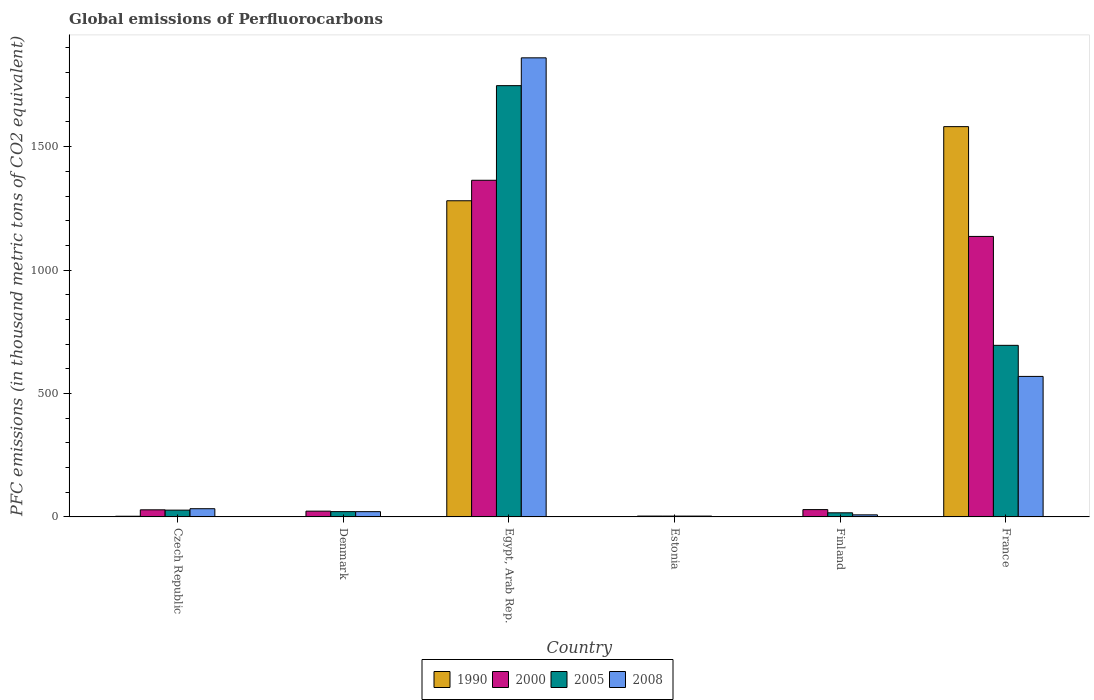How many different coloured bars are there?
Offer a very short reply. 4. How many bars are there on the 6th tick from the left?
Your answer should be very brief. 4. What is the label of the 2nd group of bars from the left?
Your answer should be very brief. Denmark. What is the global emissions of Perfluorocarbons in 1990 in Finland?
Your answer should be very brief. 1.7. Across all countries, what is the maximum global emissions of Perfluorocarbons in 2005?
Give a very brief answer. 1747.1. Across all countries, what is the minimum global emissions of Perfluorocarbons in 1990?
Offer a terse response. 0.5. In which country was the global emissions of Perfluorocarbons in 2008 maximum?
Your answer should be compact. Egypt, Arab Rep. In which country was the global emissions of Perfluorocarbons in 2005 minimum?
Give a very brief answer. Estonia. What is the total global emissions of Perfluorocarbons in 1990 in the graph?
Offer a very short reply. 2868.3. What is the difference between the global emissions of Perfluorocarbons in 1990 in Finland and that in France?
Offer a terse response. -1579.4. What is the difference between the global emissions of Perfluorocarbons in 2005 in Denmark and the global emissions of Perfluorocarbons in 2008 in Czech Republic?
Make the answer very short. -11.8. What is the average global emissions of Perfluorocarbons in 1990 per country?
Your answer should be compact. 478.05. What is the difference between the global emissions of Perfluorocarbons of/in 2005 and global emissions of Perfluorocarbons of/in 2000 in Finland?
Ensure brevity in your answer.  -13. In how many countries, is the global emissions of Perfluorocarbons in 2008 greater than 700 thousand metric tons?
Provide a short and direct response. 1. What is the ratio of the global emissions of Perfluorocarbons in 2005 in Egypt, Arab Rep. to that in France?
Your answer should be compact. 2.51. Is the global emissions of Perfluorocarbons in 1990 in Egypt, Arab Rep. less than that in Finland?
Your answer should be compact. No. Is the difference between the global emissions of Perfluorocarbons in 2005 in Czech Republic and Denmark greater than the difference between the global emissions of Perfluorocarbons in 2000 in Czech Republic and Denmark?
Ensure brevity in your answer.  Yes. What is the difference between the highest and the second highest global emissions of Perfluorocarbons in 2005?
Offer a very short reply. -1719.6. What is the difference between the highest and the lowest global emissions of Perfluorocarbons in 2005?
Provide a short and direct response. 1743.7. Is it the case that in every country, the sum of the global emissions of Perfluorocarbons in 2000 and global emissions of Perfluorocarbons in 2005 is greater than the sum of global emissions of Perfluorocarbons in 1990 and global emissions of Perfluorocarbons in 2008?
Your answer should be compact. No. What does the 4th bar from the left in Finland represents?
Offer a terse response. 2008. What does the 2nd bar from the right in Finland represents?
Give a very brief answer. 2005. Are the values on the major ticks of Y-axis written in scientific E-notation?
Your response must be concise. No. Does the graph contain grids?
Your answer should be very brief. No. How many legend labels are there?
Offer a very short reply. 4. How are the legend labels stacked?
Offer a very short reply. Horizontal. What is the title of the graph?
Ensure brevity in your answer.  Global emissions of Perfluorocarbons. What is the label or title of the X-axis?
Your answer should be compact. Country. What is the label or title of the Y-axis?
Your answer should be compact. PFC emissions (in thousand metric tons of CO2 equivalent). What is the PFC emissions (in thousand metric tons of CO2 equivalent) of 1990 in Czech Republic?
Offer a terse response. 2.8. What is the PFC emissions (in thousand metric tons of CO2 equivalent) of 2000 in Czech Republic?
Provide a short and direct response. 28.8. What is the PFC emissions (in thousand metric tons of CO2 equivalent) of 2008 in Czech Republic?
Give a very brief answer. 33.3. What is the PFC emissions (in thousand metric tons of CO2 equivalent) of 1990 in Denmark?
Keep it short and to the point. 1.4. What is the PFC emissions (in thousand metric tons of CO2 equivalent) in 2000 in Denmark?
Keep it short and to the point. 23.4. What is the PFC emissions (in thousand metric tons of CO2 equivalent) of 2005 in Denmark?
Provide a succinct answer. 21.5. What is the PFC emissions (in thousand metric tons of CO2 equivalent) of 2008 in Denmark?
Your response must be concise. 21.4. What is the PFC emissions (in thousand metric tons of CO2 equivalent) in 1990 in Egypt, Arab Rep.?
Provide a short and direct response. 1280.8. What is the PFC emissions (in thousand metric tons of CO2 equivalent) of 2000 in Egypt, Arab Rep.?
Keep it short and to the point. 1363.8. What is the PFC emissions (in thousand metric tons of CO2 equivalent) in 2005 in Egypt, Arab Rep.?
Make the answer very short. 1747.1. What is the PFC emissions (in thousand metric tons of CO2 equivalent) in 2008 in Egypt, Arab Rep.?
Your answer should be compact. 1859.8. What is the PFC emissions (in thousand metric tons of CO2 equivalent) of 1990 in Estonia?
Ensure brevity in your answer.  0.5. What is the PFC emissions (in thousand metric tons of CO2 equivalent) of 2005 in Estonia?
Provide a succinct answer. 3.4. What is the PFC emissions (in thousand metric tons of CO2 equivalent) of 2008 in Estonia?
Your answer should be compact. 3.4. What is the PFC emissions (in thousand metric tons of CO2 equivalent) in 1990 in Finland?
Ensure brevity in your answer.  1.7. What is the PFC emissions (in thousand metric tons of CO2 equivalent) of 2000 in Finland?
Your response must be concise. 29.7. What is the PFC emissions (in thousand metric tons of CO2 equivalent) in 2005 in Finland?
Give a very brief answer. 16.7. What is the PFC emissions (in thousand metric tons of CO2 equivalent) of 2008 in Finland?
Make the answer very short. 8.4. What is the PFC emissions (in thousand metric tons of CO2 equivalent) in 1990 in France?
Keep it short and to the point. 1581.1. What is the PFC emissions (in thousand metric tons of CO2 equivalent) in 2000 in France?
Your response must be concise. 1136.3. What is the PFC emissions (in thousand metric tons of CO2 equivalent) of 2005 in France?
Provide a succinct answer. 695.1. What is the PFC emissions (in thousand metric tons of CO2 equivalent) in 2008 in France?
Your response must be concise. 569.2. Across all countries, what is the maximum PFC emissions (in thousand metric tons of CO2 equivalent) in 1990?
Provide a short and direct response. 1581.1. Across all countries, what is the maximum PFC emissions (in thousand metric tons of CO2 equivalent) in 2000?
Offer a very short reply. 1363.8. Across all countries, what is the maximum PFC emissions (in thousand metric tons of CO2 equivalent) in 2005?
Keep it short and to the point. 1747.1. Across all countries, what is the maximum PFC emissions (in thousand metric tons of CO2 equivalent) in 2008?
Give a very brief answer. 1859.8. Across all countries, what is the minimum PFC emissions (in thousand metric tons of CO2 equivalent) in 2000?
Ensure brevity in your answer.  3.5. What is the total PFC emissions (in thousand metric tons of CO2 equivalent) in 1990 in the graph?
Your answer should be very brief. 2868.3. What is the total PFC emissions (in thousand metric tons of CO2 equivalent) in 2000 in the graph?
Ensure brevity in your answer.  2585.5. What is the total PFC emissions (in thousand metric tons of CO2 equivalent) in 2005 in the graph?
Your answer should be compact. 2511.3. What is the total PFC emissions (in thousand metric tons of CO2 equivalent) of 2008 in the graph?
Make the answer very short. 2495.5. What is the difference between the PFC emissions (in thousand metric tons of CO2 equivalent) of 2000 in Czech Republic and that in Denmark?
Give a very brief answer. 5.4. What is the difference between the PFC emissions (in thousand metric tons of CO2 equivalent) in 2008 in Czech Republic and that in Denmark?
Ensure brevity in your answer.  11.9. What is the difference between the PFC emissions (in thousand metric tons of CO2 equivalent) in 1990 in Czech Republic and that in Egypt, Arab Rep.?
Your response must be concise. -1278. What is the difference between the PFC emissions (in thousand metric tons of CO2 equivalent) in 2000 in Czech Republic and that in Egypt, Arab Rep.?
Provide a short and direct response. -1335. What is the difference between the PFC emissions (in thousand metric tons of CO2 equivalent) in 2005 in Czech Republic and that in Egypt, Arab Rep.?
Keep it short and to the point. -1719.6. What is the difference between the PFC emissions (in thousand metric tons of CO2 equivalent) in 2008 in Czech Republic and that in Egypt, Arab Rep.?
Your answer should be very brief. -1826.5. What is the difference between the PFC emissions (in thousand metric tons of CO2 equivalent) in 2000 in Czech Republic and that in Estonia?
Offer a very short reply. 25.3. What is the difference between the PFC emissions (in thousand metric tons of CO2 equivalent) in 2005 in Czech Republic and that in Estonia?
Your answer should be compact. 24.1. What is the difference between the PFC emissions (in thousand metric tons of CO2 equivalent) in 2008 in Czech Republic and that in Estonia?
Make the answer very short. 29.9. What is the difference between the PFC emissions (in thousand metric tons of CO2 equivalent) in 1990 in Czech Republic and that in Finland?
Give a very brief answer. 1.1. What is the difference between the PFC emissions (in thousand metric tons of CO2 equivalent) of 2008 in Czech Republic and that in Finland?
Offer a very short reply. 24.9. What is the difference between the PFC emissions (in thousand metric tons of CO2 equivalent) of 1990 in Czech Republic and that in France?
Your answer should be compact. -1578.3. What is the difference between the PFC emissions (in thousand metric tons of CO2 equivalent) of 2000 in Czech Republic and that in France?
Ensure brevity in your answer.  -1107.5. What is the difference between the PFC emissions (in thousand metric tons of CO2 equivalent) in 2005 in Czech Republic and that in France?
Your answer should be very brief. -667.6. What is the difference between the PFC emissions (in thousand metric tons of CO2 equivalent) of 2008 in Czech Republic and that in France?
Provide a succinct answer. -535.9. What is the difference between the PFC emissions (in thousand metric tons of CO2 equivalent) of 1990 in Denmark and that in Egypt, Arab Rep.?
Your answer should be compact. -1279.4. What is the difference between the PFC emissions (in thousand metric tons of CO2 equivalent) of 2000 in Denmark and that in Egypt, Arab Rep.?
Your answer should be compact. -1340.4. What is the difference between the PFC emissions (in thousand metric tons of CO2 equivalent) of 2005 in Denmark and that in Egypt, Arab Rep.?
Make the answer very short. -1725.6. What is the difference between the PFC emissions (in thousand metric tons of CO2 equivalent) in 2008 in Denmark and that in Egypt, Arab Rep.?
Ensure brevity in your answer.  -1838.4. What is the difference between the PFC emissions (in thousand metric tons of CO2 equivalent) of 1990 in Denmark and that in Estonia?
Give a very brief answer. 0.9. What is the difference between the PFC emissions (in thousand metric tons of CO2 equivalent) of 2000 in Denmark and that in Estonia?
Offer a terse response. 19.9. What is the difference between the PFC emissions (in thousand metric tons of CO2 equivalent) in 2005 in Denmark and that in Estonia?
Keep it short and to the point. 18.1. What is the difference between the PFC emissions (in thousand metric tons of CO2 equivalent) in 1990 in Denmark and that in Finland?
Offer a terse response. -0.3. What is the difference between the PFC emissions (in thousand metric tons of CO2 equivalent) in 2000 in Denmark and that in Finland?
Give a very brief answer. -6.3. What is the difference between the PFC emissions (in thousand metric tons of CO2 equivalent) in 2008 in Denmark and that in Finland?
Ensure brevity in your answer.  13. What is the difference between the PFC emissions (in thousand metric tons of CO2 equivalent) of 1990 in Denmark and that in France?
Offer a terse response. -1579.7. What is the difference between the PFC emissions (in thousand metric tons of CO2 equivalent) in 2000 in Denmark and that in France?
Offer a very short reply. -1112.9. What is the difference between the PFC emissions (in thousand metric tons of CO2 equivalent) in 2005 in Denmark and that in France?
Give a very brief answer. -673.6. What is the difference between the PFC emissions (in thousand metric tons of CO2 equivalent) of 2008 in Denmark and that in France?
Your answer should be compact. -547.8. What is the difference between the PFC emissions (in thousand metric tons of CO2 equivalent) in 1990 in Egypt, Arab Rep. and that in Estonia?
Your response must be concise. 1280.3. What is the difference between the PFC emissions (in thousand metric tons of CO2 equivalent) in 2000 in Egypt, Arab Rep. and that in Estonia?
Your response must be concise. 1360.3. What is the difference between the PFC emissions (in thousand metric tons of CO2 equivalent) in 2005 in Egypt, Arab Rep. and that in Estonia?
Your answer should be compact. 1743.7. What is the difference between the PFC emissions (in thousand metric tons of CO2 equivalent) in 2008 in Egypt, Arab Rep. and that in Estonia?
Your response must be concise. 1856.4. What is the difference between the PFC emissions (in thousand metric tons of CO2 equivalent) in 1990 in Egypt, Arab Rep. and that in Finland?
Make the answer very short. 1279.1. What is the difference between the PFC emissions (in thousand metric tons of CO2 equivalent) of 2000 in Egypt, Arab Rep. and that in Finland?
Ensure brevity in your answer.  1334.1. What is the difference between the PFC emissions (in thousand metric tons of CO2 equivalent) in 2005 in Egypt, Arab Rep. and that in Finland?
Make the answer very short. 1730.4. What is the difference between the PFC emissions (in thousand metric tons of CO2 equivalent) of 2008 in Egypt, Arab Rep. and that in Finland?
Provide a short and direct response. 1851.4. What is the difference between the PFC emissions (in thousand metric tons of CO2 equivalent) of 1990 in Egypt, Arab Rep. and that in France?
Provide a succinct answer. -300.3. What is the difference between the PFC emissions (in thousand metric tons of CO2 equivalent) of 2000 in Egypt, Arab Rep. and that in France?
Your response must be concise. 227.5. What is the difference between the PFC emissions (in thousand metric tons of CO2 equivalent) of 2005 in Egypt, Arab Rep. and that in France?
Provide a short and direct response. 1052. What is the difference between the PFC emissions (in thousand metric tons of CO2 equivalent) of 2008 in Egypt, Arab Rep. and that in France?
Your response must be concise. 1290.6. What is the difference between the PFC emissions (in thousand metric tons of CO2 equivalent) of 1990 in Estonia and that in Finland?
Provide a succinct answer. -1.2. What is the difference between the PFC emissions (in thousand metric tons of CO2 equivalent) of 2000 in Estonia and that in Finland?
Your answer should be very brief. -26.2. What is the difference between the PFC emissions (in thousand metric tons of CO2 equivalent) in 2005 in Estonia and that in Finland?
Give a very brief answer. -13.3. What is the difference between the PFC emissions (in thousand metric tons of CO2 equivalent) in 2008 in Estonia and that in Finland?
Give a very brief answer. -5. What is the difference between the PFC emissions (in thousand metric tons of CO2 equivalent) in 1990 in Estonia and that in France?
Your answer should be compact. -1580.6. What is the difference between the PFC emissions (in thousand metric tons of CO2 equivalent) in 2000 in Estonia and that in France?
Offer a terse response. -1132.8. What is the difference between the PFC emissions (in thousand metric tons of CO2 equivalent) in 2005 in Estonia and that in France?
Offer a terse response. -691.7. What is the difference between the PFC emissions (in thousand metric tons of CO2 equivalent) in 2008 in Estonia and that in France?
Offer a terse response. -565.8. What is the difference between the PFC emissions (in thousand metric tons of CO2 equivalent) of 1990 in Finland and that in France?
Ensure brevity in your answer.  -1579.4. What is the difference between the PFC emissions (in thousand metric tons of CO2 equivalent) in 2000 in Finland and that in France?
Your answer should be very brief. -1106.6. What is the difference between the PFC emissions (in thousand metric tons of CO2 equivalent) in 2005 in Finland and that in France?
Give a very brief answer. -678.4. What is the difference between the PFC emissions (in thousand metric tons of CO2 equivalent) in 2008 in Finland and that in France?
Offer a terse response. -560.8. What is the difference between the PFC emissions (in thousand metric tons of CO2 equivalent) of 1990 in Czech Republic and the PFC emissions (in thousand metric tons of CO2 equivalent) of 2000 in Denmark?
Keep it short and to the point. -20.6. What is the difference between the PFC emissions (in thousand metric tons of CO2 equivalent) of 1990 in Czech Republic and the PFC emissions (in thousand metric tons of CO2 equivalent) of 2005 in Denmark?
Your answer should be very brief. -18.7. What is the difference between the PFC emissions (in thousand metric tons of CO2 equivalent) of 1990 in Czech Republic and the PFC emissions (in thousand metric tons of CO2 equivalent) of 2008 in Denmark?
Your answer should be very brief. -18.6. What is the difference between the PFC emissions (in thousand metric tons of CO2 equivalent) of 1990 in Czech Republic and the PFC emissions (in thousand metric tons of CO2 equivalent) of 2000 in Egypt, Arab Rep.?
Your answer should be very brief. -1361. What is the difference between the PFC emissions (in thousand metric tons of CO2 equivalent) in 1990 in Czech Republic and the PFC emissions (in thousand metric tons of CO2 equivalent) in 2005 in Egypt, Arab Rep.?
Give a very brief answer. -1744.3. What is the difference between the PFC emissions (in thousand metric tons of CO2 equivalent) of 1990 in Czech Republic and the PFC emissions (in thousand metric tons of CO2 equivalent) of 2008 in Egypt, Arab Rep.?
Ensure brevity in your answer.  -1857. What is the difference between the PFC emissions (in thousand metric tons of CO2 equivalent) in 2000 in Czech Republic and the PFC emissions (in thousand metric tons of CO2 equivalent) in 2005 in Egypt, Arab Rep.?
Offer a very short reply. -1718.3. What is the difference between the PFC emissions (in thousand metric tons of CO2 equivalent) in 2000 in Czech Republic and the PFC emissions (in thousand metric tons of CO2 equivalent) in 2008 in Egypt, Arab Rep.?
Your answer should be compact. -1831. What is the difference between the PFC emissions (in thousand metric tons of CO2 equivalent) in 2005 in Czech Republic and the PFC emissions (in thousand metric tons of CO2 equivalent) in 2008 in Egypt, Arab Rep.?
Provide a succinct answer. -1832.3. What is the difference between the PFC emissions (in thousand metric tons of CO2 equivalent) in 1990 in Czech Republic and the PFC emissions (in thousand metric tons of CO2 equivalent) in 2000 in Estonia?
Offer a terse response. -0.7. What is the difference between the PFC emissions (in thousand metric tons of CO2 equivalent) of 1990 in Czech Republic and the PFC emissions (in thousand metric tons of CO2 equivalent) of 2008 in Estonia?
Make the answer very short. -0.6. What is the difference between the PFC emissions (in thousand metric tons of CO2 equivalent) in 2000 in Czech Republic and the PFC emissions (in thousand metric tons of CO2 equivalent) in 2005 in Estonia?
Your answer should be compact. 25.4. What is the difference between the PFC emissions (in thousand metric tons of CO2 equivalent) in 2000 in Czech Republic and the PFC emissions (in thousand metric tons of CO2 equivalent) in 2008 in Estonia?
Keep it short and to the point. 25.4. What is the difference between the PFC emissions (in thousand metric tons of CO2 equivalent) of 2005 in Czech Republic and the PFC emissions (in thousand metric tons of CO2 equivalent) of 2008 in Estonia?
Keep it short and to the point. 24.1. What is the difference between the PFC emissions (in thousand metric tons of CO2 equivalent) of 1990 in Czech Republic and the PFC emissions (in thousand metric tons of CO2 equivalent) of 2000 in Finland?
Ensure brevity in your answer.  -26.9. What is the difference between the PFC emissions (in thousand metric tons of CO2 equivalent) in 1990 in Czech Republic and the PFC emissions (in thousand metric tons of CO2 equivalent) in 2008 in Finland?
Make the answer very short. -5.6. What is the difference between the PFC emissions (in thousand metric tons of CO2 equivalent) of 2000 in Czech Republic and the PFC emissions (in thousand metric tons of CO2 equivalent) of 2008 in Finland?
Ensure brevity in your answer.  20.4. What is the difference between the PFC emissions (in thousand metric tons of CO2 equivalent) in 1990 in Czech Republic and the PFC emissions (in thousand metric tons of CO2 equivalent) in 2000 in France?
Your answer should be very brief. -1133.5. What is the difference between the PFC emissions (in thousand metric tons of CO2 equivalent) in 1990 in Czech Republic and the PFC emissions (in thousand metric tons of CO2 equivalent) in 2005 in France?
Provide a succinct answer. -692.3. What is the difference between the PFC emissions (in thousand metric tons of CO2 equivalent) in 1990 in Czech Republic and the PFC emissions (in thousand metric tons of CO2 equivalent) in 2008 in France?
Provide a succinct answer. -566.4. What is the difference between the PFC emissions (in thousand metric tons of CO2 equivalent) of 2000 in Czech Republic and the PFC emissions (in thousand metric tons of CO2 equivalent) of 2005 in France?
Make the answer very short. -666.3. What is the difference between the PFC emissions (in thousand metric tons of CO2 equivalent) of 2000 in Czech Republic and the PFC emissions (in thousand metric tons of CO2 equivalent) of 2008 in France?
Your answer should be compact. -540.4. What is the difference between the PFC emissions (in thousand metric tons of CO2 equivalent) of 2005 in Czech Republic and the PFC emissions (in thousand metric tons of CO2 equivalent) of 2008 in France?
Your answer should be compact. -541.7. What is the difference between the PFC emissions (in thousand metric tons of CO2 equivalent) in 1990 in Denmark and the PFC emissions (in thousand metric tons of CO2 equivalent) in 2000 in Egypt, Arab Rep.?
Your answer should be very brief. -1362.4. What is the difference between the PFC emissions (in thousand metric tons of CO2 equivalent) in 1990 in Denmark and the PFC emissions (in thousand metric tons of CO2 equivalent) in 2005 in Egypt, Arab Rep.?
Provide a short and direct response. -1745.7. What is the difference between the PFC emissions (in thousand metric tons of CO2 equivalent) of 1990 in Denmark and the PFC emissions (in thousand metric tons of CO2 equivalent) of 2008 in Egypt, Arab Rep.?
Provide a succinct answer. -1858.4. What is the difference between the PFC emissions (in thousand metric tons of CO2 equivalent) of 2000 in Denmark and the PFC emissions (in thousand metric tons of CO2 equivalent) of 2005 in Egypt, Arab Rep.?
Offer a terse response. -1723.7. What is the difference between the PFC emissions (in thousand metric tons of CO2 equivalent) in 2000 in Denmark and the PFC emissions (in thousand metric tons of CO2 equivalent) in 2008 in Egypt, Arab Rep.?
Offer a very short reply. -1836.4. What is the difference between the PFC emissions (in thousand metric tons of CO2 equivalent) of 2005 in Denmark and the PFC emissions (in thousand metric tons of CO2 equivalent) of 2008 in Egypt, Arab Rep.?
Give a very brief answer. -1838.3. What is the difference between the PFC emissions (in thousand metric tons of CO2 equivalent) of 1990 in Denmark and the PFC emissions (in thousand metric tons of CO2 equivalent) of 2008 in Estonia?
Offer a terse response. -2. What is the difference between the PFC emissions (in thousand metric tons of CO2 equivalent) in 2000 in Denmark and the PFC emissions (in thousand metric tons of CO2 equivalent) in 2008 in Estonia?
Provide a short and direct response. 20. What is the difference between the PFC emissions (in thousand metric tons of CO2 equivalent) of 1990 in Denmark and the PFC emissions (in thousand metric tons of CO2 equivalent) of 2000 in Finland?
Provide a succinct answer. -28.3. What is the difference between the PFC emissions (in thousand metric tons of CO2 equivalent) of 1990 in Denmark and the PFC emissions (in thousand metric tons of CO2 equivalent) of 2005 in Finland?
Your answer should be very brief. -15.3. What is the difference between the PFC emissions (in thousand metric tons of CO2 equivalent) in 2000 in Denmark and the PFC emissions (in thousand metric tons of CO2 equivalent) in 2005 in Finland?
Your response must be concise. 6.7. What is the difference between the PFC emissions (in thousand metric tons of CO2 equivalent) in 2005 in Denmark and the PFC emissions (in thousand metric tons of CO2 equivalent) in 2008 in Finland?
Ensure brevity in your answer.  13.1. What is the difference between the PFC emissions (in thousand metric tons of CO2 equivalent) of 1990 in Denmark and the PFC emissions (in thousand metric tons of CO2 equivalent) of 2000 in France?
Give a very brief answer. -1134.9. What is the difference between the PFC emissions (in thousand metric tons of CO2 equivalent) of 1990 in Denmark and the PFC emissions (in thousand metric tons of CO2 equivalent) of 2005 in France?
Provide a succinct answer. -693.7. What is the difference between the PFC emissions (in thousand metric tons of CO2 equivalent) in 1990 in Denmark and the PFC emissions (in thousand metric tons of CO2 equivalent) in 2008 in France?
Provide a succinct answer. -567.8. What is the difference between the PFC emissions (in thousand metric tons of CO2 equivalent) in 2000 in Denmark and the PFC emissions (in thousand metric tons of CO2 equivalent) in 2005 in France?
Your answer should be compact. -671.7. What is the difference between the PFC emissions (in thousand metric tons of CO2 equivalent) of 2000 in Denmark and the PFC emissions (in thousand metric tons of CO2 equivalent) of 2008 in France?
Provide a succinct answer. -545.8. What is the difference between the PFC emissions (in thousand metric tons of CO2 equivalent) of 2005 in Denmark and the PFC emissions (in thousand metric tons of CO2 equivalent) of 2008 in France?
Make the answer very short. -547.7. What is the difference between the PFC emissions (in thousand metric tons of CO2 equivalent) in 1990 in Egypt, Arab Rep. and the PFC emissions (in thousand metric tons of CO2 equivalent) in 2000 in Estonia?
Make the answer very short. 1277.3. What is the difference between the PFC emissions (in thousand metric tons of CO2 equivalent) of 1990 in Egypt, Arab Rep. and the PFC emissions (in thousand metric tons of CO2 equivalent) of 2005 in Estonia?
Ensure brevity in your answer.  1277.4. What is the difference between the PFC emissions (in thousand metric tons of CO2 equivalent) in 1990 in Egypt, Arab Rep. and the PFC emissions (in thousand metric tons of CO2 equivalent) in 2008 in Estonia?
Make the answer very short. 1277.4. What is the difference between the PFC emissions (in thousand metric tons of CO2 equivalent) of 2000 in Egypt, Arab Rep. and the PFC emissions (in thousand metric tons of CO2 equivalent) of 2005 in Estonia?
Your answer should be compact. 1360.4. What is the difference between the PFC emissions (in thousand metric tons of CO2 equivalent) of 2000 in Egypt, Arab Rep. and the PFC emissions (in thousand metric tons of CO2 equivalent) of 2008 in Estonia?
Offer a very short reply. 1360.4. What is the difference between the PFC emissions (in thousand metric tons of CO2 equivalent) of 2005 in Egypt, Arab Rep. and the PFC emissions (in thousand metric tons of CO2 equivalent) of 2008 in Estonia?
Your answer should be compact. 1743.7. What is the difference between the PFC emissions (in thousand metric tons of CO2 equivalent) in 1990 in Egypt, Arab Rep. and the PFC emissions (in thousand metric tons of CO2 equivalent) in 2000 in Finland?
Ensure brevity in your answer.  1251.1. What is the difference between the PFC emissions (in thousand metric tons of CO2 equivalent) of 1990 in Egypt, Arab Rep. and the PFC emissions (in thousand metric tons of CO2 equivalent) of 2005 in Finland?
Provide a short and direct response. 1264.1. What is the difference between the PFC emissions (in thousand metric tons of CO2 equivalent) in 1990 in Egypt, Arab Rep. and the PFC emissions (in thousand metric tons of CO2 equivalent) in 2008 in Finland?
Your response must be concise. 1272.4. What is the difference between the PFC emissions (in thousand metric tons of CO2 equivalent) in 2000 in Egypt, Arab Rep. and the PFC emissions (in thousand metric tons of CO2 equivalent) in 2005 in Finland?
Make the answer very short. 1347.1. What is the difference between the PFC emissions (in thousand metric tons of CO2 equivalent) of 2000 in Egypt, Arab Rep. and the PFC emissions (in thousand metric tons of CO2 equivalent) of 2008 in Finland?
Give a very brief answer. 1355.4. What is the difference between the PFC emissions (in thousand metric tons of CO2 equivalent) in 2005 in Egypt, Arab Rep. and the PFC emissions (in thousand metric tons of CO2 equivalent) in 2008 in Finland?
Provide a succinct answer. 1738.7. What is the difference between the PFC emissions (in thousand metric tons of CO2 equivalent) in 1990 in Egypt, Arab Rep. and the PFC emissions (in thousand metric tons of CO2 equivalent) in 2000 in France?
Offer a very short reply. 144.5. What is the difference between the PFC emissions (in thousand metric tons of CO2 equivalent) of 1990 in Egypt, Arab Rep. and the PFC emissions (in thousand metric tons of CO2 equivalent) of 2005 in France?
Make the answer very short. 585.7. What is the difference between the PFC emissions (in thousand metric tons of CO2 equivalent) in 1990 in Egypt, Arab Rep. and the PFC emissions (in thousand metric tons of CO2 equivalent) in 2008 in France?
Provide a succinct answer. 711.6. What is the difference between the PFC emissions (in thousand metric tons of CO2 equivalent) in 2000 in Egypt, Arab Rep. and the PFC emissions (in thousand metric tons of CO2 equivalent) in 2005 in France?
Provide a succinct answer. 668.7. What is the difference between the PFC emissions (in thousand metric tons of CO2 equivalent) in 2000 in Egypt, Arab Rep. and the PFC emissions (in thousand metric tons of CO2 equivalent) in 2008 in France?
Make the answer very short. 794.6. What is the difference between the PFC emissions (in thousand metric tons of CO2 equivalent) in 2005 in Egypt, Arab Rep. and the PFC emissions (in thousand metric tons of CO2 equivalent) in 2008 in France?
Offer a very short reply. 1177.9. What is the difference between the PFC emissions (in thousand metric tons of CO2 equivalent) of 1990 in Estonia and the PFC emissions (in thousand metric tons of CO2 equivalent) of 2000 in Finland?
Make the answer very short. -29.2. What is the difference between the PFC emissions (in thousand metric tons of CO2 equivalent) in 1990 in Estonia and the PFC emissions (in thousand metric tons of CO2 equivalent) in 2005 in Finland?
Provide a short and direct response. -16.2. What is the difference between the PFC emissions (in thousand metric tons of CO2 equivalent) of 1990 in Estonia and the PFC emissions (in thousand metric tons of CO2 equivalent) of 2008 in Finland?
Keep it short and to the point. -7.9. What is the difference between the PFC emissions (in thousand metric tons of CO2 equivalent) in 2000 in Estonia and the PFC emissions (in thousand metric tons of CO2 equivalent) in 2008 in Finland?
Give a very brief answer. -4.9. What is the difference between the PFC emissions (in thousand metric tons of CO2 equivalent) of 2005 in Estonia and the PFC emissions (in thousand metric tons of CO2 equivalent) of 2008 in Finland?
Provide a short and direct response. -5. What is the difference between the PFC emissions (in thousand metric tons of CO2 equivalent) of 1990 in Estonia and the PFC emissions (in thousand metric tons of CO2 equivalent) of 2000 in France?
Your response must be concise. -1135.8. What is the difference between the PFC emissions (in thousand metric tons of CO2 equivalent) of 1990 in Estonia and the PFC emissions (in thousand metric tons of CO2 equivalent) of 2005 in France?
Your answer should be very brief. -694.6. What is the difference between the PFC emissions (in thousand metric tons of CO2 equivalent) in 1990 in Estonia and the PFC emissions (in thousand metric tons of CO2 equivalent) in 2008 in France?
Ensure brevity in your answer.  -568.7. What is the difference between the PFC emissions (in thousand metric tons of CO2 equivalent) in 2000 in Estonia and the PFC emissions (in thousand metric tons of CO2 equivalent) in 2005 in France?
Keep it short and to the point. -691.6. What is the difference between the PFC emissions (in thousand metric tons of CO2 equivalent) of 2000 in Estonia and the PFC emissions (in thousand metric tons of CO2 equivalent) of 2008 in France?
Give a very brief answer. -565.7. What is the difference between the PFC emissions (in thousand metric tons of CO2 equivalent) in 2005 in Estonia and the PFC emissions (in thousand metric tons of CO2 equivalent) in 2008 in France?
Make the answer very short. -565.8. What is the difference between the PFC emissions (in thousand metric tons of CO2 equivalent) of 1990 in Finland and the PFC emissions (in thousand metric tons of CO2 equivalent) of 2000 in France?
Your answer should be compact. -1134.6. What is the difference between the PFC emissions (in thousand metric tons of CO2 equivalent) in 1990 in Finland and the PFC emissions (in thousand metric tons of CO2 equivalent) in 2005 in France?
Your answer should be compact. -693.4. What is the difference between the PFC emissions (in thousand metric tons of CO2 equivalent) of 1990 in Finland and the PFC emissions (in thousand metric tons of CO2 equivalent) of 2008 in France?
Your answer should be very brief. -567.5. What is the difference between the PFC emissions (in thousand metric tons of CO2 equivalent) of 2000 in Finland and the PFC emissions (in thousand metric tons of CO2 equivalent) of 2005 in France?
Offer a very short reply. -665.4. What is the difference between the PFC emissions (in thousand metric tons of CO2 equivalent) of 2000 in Finland and the PFC emissions (in thousand metric tons of CO2 equivalent) of 2008 in France?
Make the answer very short. -539.5. What is the difference between the PFC emissions (in thousand metric tons of CO2 equivalent) of 2005 in Finland and the PFC emissions (in thousand metric tons of CO2 equivalent) of 2008 in France?
Ensure brevity in your answer.  -552.5. What is the average PFC emissions (in thousand metric tons of CO2 equivalent) of 1990 per country?
Keep it short and to the point. 478.05. What is the average PFC emissions (in thousand metric tons of CO2 equivalent) of 2000 per country?
Ensure brevity in your answer.  430.92. What is the average PFC emissions (in thousand metric tons of CO2 equivalent) in 2005 per country?
Offer a very short reply. 418.55. What is the average PFC emissions (in thousand metric tons of CO2 equivalent) of 2008 per country?
Offer a very short reply. 415.92. What is the difference between the PFC emissions (in thousand metric tons of CO2 equivalent) in 1990 and PFC emissions (in thousand metric tons of CO2 equivalent) in 2000 in Czech Republic?
Your answer should be compact. -26. What is the difference between the PFC emissions (in thousand metric tons of CO2 equivalent) in 1990 and PFC emissions (in thousand metric tons of CO2 equivalent) in 2005 in Czech Republic?
Provide a succinct answer. -24.7. What is the difference between the PFC emissions (in thousand metric tons of CO2 equivalent) of 1990 and PFC emissions (in thousand metric tons of CO2 equivalent) of 2008 in Czech Republic?
Provide a succinct answer. -30.5. What is the difference between the PFC emissions (in thousand metric tons of CO2 equivalent) in 1990 and PFC emissions (in thousand metric tons of CO2 equivalent) in 2005 in Denmark?
Your answer should be very brief. -20.1. What is the difference between the PFC emissions (in thousand metric tons of CO2 equivalent) in 2000 and PFC emissions (in thousand metric tons of CO2 equivalent) in 2005 in Denmark?
Your answer should be compact. 1.9. What is the difference between the PFC emissions (in thousand metric tons of CO2 equivalent) in 2005 and PFC emissions (in thousand metric tons of CO2 equivalent) in 2008 in Denmark?
Give a very brief answer. 0.1. What is the difference between the PFC emissions (in thousand metric tons of CO2 equivalent) of 1990 and PFC emissions (in thousand metric tons of CO2 equivalent) of 2000 in Egypt, Arab Rep.?
Your response must be concise. -83. What is the difference between the PFC emissions (in thousand metric tons of CO2 equivalent) in 1990 and PFC emissions (in thousand metric tons of CO2 equivalent) in 2005 in Egypt, Arab Rep.?
Provide a short and direct response. -466.3. What is the difference between the PFC emissions (in thousand metric tons of CO2 equivalent) of 1990 and PFC emissions (in thousand metric tons of CO2 equivalent) of 2008 in Egypt, Arab Rep.?
Keep it short and to the point. -579. What is the difference between the PFC emissions (in thousand metric tons of CO2 equivalent) in 2000 and PFC emissions (in thousand metric tons of CO2 equivalent) in 2005 in Egypt, Arab Rep.?
Provide a succinct answer. -383.3. What is the difference between the PFC emissions (in thousand metric tons of CO2 equivalent) of 2000 and PFC emissions (in thousand metric tons of CO2 equivalent) of 2008 in Egypt, Arab Rep.?
Offer a terse response. -496. What is the difference between the PFC emissions (in thousand metric tons of CO2 equivalent) in 2005 and PFC emissions (in thousand metric tons of CO2 equivalent) in 2008 in Egypt, Arab Rep.?
Ensure brevity in your answer.  -112.7. What is the difference between the PFC emissions (in thousand metric tons of CO2 equivalent) in 2000 and PFC emissions (in thousand metric tons of CO2 equivalent) in 2005 in Estonia?
Your answer should be compact. 0.1. What is the difference between the PFC emissions (in thousand metric tons of CO2 equivalent) of 1990 and PFC emissions (in thousand metric tons of CO2 equivalent) of 2005 in Finland?
Ensure brevity in your answer.  -15. What is the difference between the PFC emissions (in thousand metric tons of CO2 equivalent) in 1990 and PFC emissions (in thousand metric tons of CO2 equivalent) in 2008 in Finland?
Give a very brief answer. -6.7. What is the difference between the PFC emissions (in thousand metric tons of CO2 equivalent) of 2000 and PFC emissions (in thousand metric tons of CO2 equivalent) of 2008 in Finland?
Provide a short and direct response. 21.3. What is the difference between the PFC emissions (in thousand metric tons of CO2 equivalent) of 1990 and PFC emissions (in thousand metric tons of CO2 equivalent) of 2000 in France?
Offer a very short reply. 444.8. What is the difference between the PFC emissions (in thousand metric tons of CO2 equivalent) in 1990 and PFC emissions (in thousand metric tons of CO2 equivalent) in 2005 in France?
Your answer should be compact. 886. What is the difference between the PFC emissions (in thousand metric tons of CO2 equivalent) in 1990 and PFC emissions (in thousand metric tons of CO2 equivalent) in 2008 in France?
Offer a very short reply. 1011.9. What is the difference between the PFC emissions (in thousand metric tons of CO2 equivalent) in 2000 and PFC emissions (in thousand metric tons of CO2 equivalent) in 2005 in France?
Keep it short and to the point. 441.2. What is the difference between the PFC emissions (in thousand metric tons of CO2 equivalent) in 2000 and PFC emissions (in thousand metric tons of CO2 equivalent) in 2008 in France?
Ensure brevity in your answer.  567.1. What is the difference between the PFC emissions (in thousand metric tons of CO2 equivalent) of 2005 and PFC emissions (in thousand metric tons of CO2 equivalent) of 2008 in France?
Your answer should be compact. 125.9. What is the ratio of the PFC emissions (in thousand metric tons of CO2 equivalent) in 2000 in Czech Republic to that in Denmark?
Your answer should be compact. 1.23. What is the ratio of the PFC emissions (in thousand metric tons of CO2 equivalent) in 2005 in Czech Republic to that in Denmark?
Your response must be concise. 1.28. What is the ratio of the PFC emissions (in thousand metric tons of CO2 equivalent) of 2008 in Czech Republic to that in Denmark?
Your answer should be very brief. 1.56. What is the ratio of the PFC emissions (in thousand metric tons of CO2 equivalent) of 1990 in Czech Republic to that in Egypt, Arab Rep.?
Provide a short and direct response. 0. What is the ratio of the PFC emissions (in thousand metric tons of CO2 equivalent) in 2000 in Czech Republic to that in Egypt, Arab Rep.?
Your answer should be very brief. 0.02. What is the ratio of the PFC emissions (in thousand metric tons of CO2 equivalent) in 2005 in Czech Republic to that in Egypt, Arab Rep.?
Offer a very short reply. 0.02. What is the ratio of the PFC emissions (in thousand metric tons of CO2 equivalent) of 2008 in Czech Republic to that in Egypt, Arab Rep.?
Ensure brevity in your answer.  0.02. What is the ratio of the PFC emissions (in thousand metric tons of CO2 equivalent) of 1990 in Czech Republic to that in Estonia?
Offer a terse response. 5.6. What is the ratio of the PFC emissions (in thousand metric tons of CO2 equivalent) in 2000 in Czech Republic to that in Estonia?
Your answer should be very brief. 8.23. What is the ratio of the PFC emissions (in thousand metric tons of CO2 equivalent) in 2005 in Czech Republic to that in Estonia?
Offer a terse response. 8.09. What is the ratio of the PFC emissions (in thousand metric tons of CO2 equivalent) in 2008 in Czech Republic to that in Estonia?
Your answer should be very brief. 9.79. What is the ratio of the PFC emissions (in thousand metric tons of CO2 equivalent) of 1990 in Czech Republic to that in Finland?
Your answer should be very brief. 1.65. What is the ratio of the PFC emissions (in thousand metric tons of CO2 equivalent) of 2000 in Czech Republic to that in Finland?
Your answer should be compact. 0.97. What is the ratio of the PFC emissions (in thousand metric tons of CO2 equivalent) in 2005 in Czech Republic to that in Finland?
Provide a succinct answer. 1.65. What is the ratio of the PFC emissions (in thousand metric tons of CO2 equivalent) in 2008 in Czech Republic to that in Finland?
Give a very brief answer. 3.96. What is the ratio of the PFC emissions (in thousand metric tons of CO2 equivalent) of 1990 in Czech Republic to that in France?
Offer a terse response. 0. What is the ratio of the PFC emissions (in thousand metric tons of CO2 equivalent) of 2000 in Czech Republic to that in France?
Keep it short and to the point. 0.03. What is the ratio of the PFC emissions (in thousand metric tons of CO2 equivalent) of 2005 in Czech Republic to that in France?
Keep it short and to the point. 0.04. What is the ratio of the PFC emissions (in thousand metric tons of CO2 equivalent) of 2008 in Czech Republic to that in France?
Give a very brief answer. 0.06. What is the ratio of the PFC emissions (in thousand metric tons of CO2 equivalent) of 1990 in Denmark to that in Egypt, Arab Rep.?
Make the answer very short. 0. What is the ratio of the PFC emissions (in thousand metric tons of CO2 equivalent) in 2000 in Denmark to that in Egypt, Arab Rep.?
Ensure brevity in your answer.  0.02. What is the ratio of the PFC emissions (in thousand metric tons of CO2 equivalent) in 2005 in Denmark to that in Egypt, Arab Rep.?
Keep it short and to the point. 0.01. What is the ratio of the PFC emissions (in thousand metric tons of CO2 equivalent) in 2008 in Denmark to that in Egypt, Arab Rep.?
Your answer should be very brief. 0.01. What is the ratio of the PFC emissions (in thousand metric tons of CO2 equivalent) in 2000 in Denmark to that in Estonia?
Your answer should be compact. 6.69. What is the ratio of the PFC emissions (in thousand metric tons of CO2 equivalent) in 2005 in Denmark to that in Estonia?
Provide a short and direct response. 6.32. What is the ratio of the PFC emissions (in thousand metric tons of CO2 equivalent) in 2008 in Denmark to that in Estonia?
Give a very brief answer. 6.29. What is the ratio of the PFC emissions (in thousand metric tons of CO2 equivalent) of 1990 in Denmark to that in Finland?
Your response must be concise. 0.82. What is the ratio of the PFC emissions (in thousand metric tons of CO2 equivalent) of 2000 in Denmark to that in Finland?
Offer a terse response. 0.79. What is the ratio of the PFC emissions (in thousand metric tons of CO2 equivalent) in 2005 in Denmark to that in Finland?
Offer a terse response. 1.29. What is the ratio of the PFC emissions (in thousand metric tons of CO2 equivalent) in 2008 in Denmark to that in Finland?
Provide a short and direct response. 2.55. What is the ratio of the PFC emissions (in thousand metric tons of CO2 equivalent) in 1990 in Denmark to that in France?
Offer a very short reply. 0. What is the ratio of the PFC emissions (in thousand metric tons of CO2 equivalent) in 2000 in Denmark to that in France?
Offer a very short reply. 0.02. What is the ratio of the PFC emissions (in thousand metric tons of CO2 equivalent) in 2005 in Denmark to that in France?
Keep it short and to the point. 0.03. What is the ratio of the PFC emissions (in thousand metric tons of CO2 equivalent) in 2008 in Denmark to that in France?
Give a very brief answer. 0.04. What is the ratio of the PFC emissions (in thousand metric tons of CO2 equivalent) of 1990 in Egypt, Arab Rep. to that in Estonia?
Offer a very short reply. 2561.6. What is the ratio of the PFC emissions (in thousand metric tons of CO2 equivalent) in 2000 in Egypt, Arab Rep. to that in Estonia?
Your answer should be compact. 389.66. What is the ratio of the PFC emissions (in thousand metric tons of CO2 equivalent) of 2005 in Egypt, Arab Rep. to that in Estonia?
Keep it short and to the point. 513.85. What is the ratio of the PFC emissions (in thousand metric tons of CO2 equivalent) of 2008 in Egypt, Arab Rep. to that in Estonia?
Your answer should be compact. 547. What is the ratio of the PFC emissions (in thousand metric tons of CO2 equivalent) of 1990 in Egypt, Arab Rep. to that in Finland?
Keep it short and to the point. 753.41. What is the ratio of the PFC emissions (in thousand metric tons of CO2 equivalent) in 2000 in Egypt, Arab Rep. to that in Finland?
Your response must be concise. 45.92. What is the ratio of the PFC emissions (in thousand metric tons of CO2 equivalent) in 2005 in Egypt, Arab Rep. to that in Finland?
Offer a terse response. 104.62. What is the ratio of the PFC emissions (in thousand metric tons of CO2 equivalent) of 2008 in Egypt, Arab Rep. to that in Finland?
Your response must be concise. 221.4. What is the ratio of the PFC emissions (in thousand metric tons of CO2 equivalent) of 1990 in Egypt, Arab Rep. to that in France?
Your response must be concise. 0.81. What is the ratio of the PFC emissions (in thousand metric tons of CO2 equivalent) in 2000 in Egypt, Arab Rep. to that in France?
Provide a succinct answer. 1.2. What is the ratio of the PFC emissions (in thousand metric tons of CO2 equivalent) in 2005 in Egypt, Arab Rep. to that in France?
Your answer should be very brief. 2.51. What is the ratio of the PFC emissions (in thousand metric tons of CO2 equivalent) of 2008 in Egypt, Arab Rep. to that in France?
Your answer should be compact. 3.27. What is the ratio of the PFC emissions (in thousand metric tons of CO2 equivalent) of 1990 in Estonia to that in Finland?
Make the answer very short. 0.29. What is the ratio of the PFC emissions (in thousand metric tons of CO2 equivalent) in 2000 in Estonia to that in Finland?
Your answer should be very brief. 0.12. What is the ratio of the PFC emissions (in thousand metric tons of CO2 equivalent) in 2005 in Estonia to that in Finland?
Your response must be concise. 0.2. What is the ratio of the PFC emissions (in thousand metric tons of CO2 equivalent) of 2008 in Estonia to that in Finland?
Keep it short and to the point. 0.4. What is the ratio of the PFC emissions (in thousand metric tons of CO2 equivalent) in 1990 in Estonia to that in France?
Offer a very short reply. 0. What is the ratio of the PFC emissions (in thousand metric tons of CO2 equivalent) in 2000 in Estonia to that in France?
Give a very brief answer. 0. What is the ratio of the PFC emissions (in thousand metric tons of CO2 equivalent) in 2005 in Estonia to that in France?
Your answer should be compact. 0. What is the ratio of the PFC emissions (in thousand metric tons of CO2 equivalent) of 2008 in Estonia to that in France?
Your answer should be very brief. 0.01. What is the ratio of the PFC emissions (in thousand metric tons of CO2 equivalent) in 1990 in Finland to that in France?
Make the answer very short. 0. What is the ratio of the PFC emissions (in thousand metric tons of CO2 equivalent) of 2000 in Finland to that in France?
Give a very brief answer. 0.03. What is the ratio of the PFC emissions (in thousand metric tons of CO2 equivalent) of 2005 in Finland to that in France?
Your response must be concise. 0.02. What is the ratio of the PFC emissions (in thousand metric tons of CO2 equivalent) of 2008 in Finland to that in France?
Give a very brief answer. 0.01. What is the difference between the highest and the second highest PFC emissions (in thousand metric tons of CO2 equivalent) of 1990?
Your answer should be very brief. 300.3. What is the difference between the highest and the second highest PFC emissions (in thousand metric tons of CO2 equivalent) in 2000?
Provide a short and direct response. 227.5. What is the difference between the highest and the second highest PFC emissions (in thousand metric tons of CO2 equivalent) in 2005?
Your answer should be compact. 1052. What is the difference between the highest and the second highest PFC emissions (in thousand metric tons of CO2 equivalent) in 2008?
Offer a terse response. 1290.6. What is the difference between the highest and the lowest PFC emissions (in thousand metric tons of CO2 equivalent) of 1990?
Provide a succinct answer. 1580.6. What is the difference between the highest and the lowest PFC emissions (in thousand metric tons of CO2 equivalent) in 2000?
Provide a short and direct response. 1360.3. What is the difference between the highest and the lowest PFC emissions (in thousand metric tons of CO2 equivalent) in 2005?
Make the answer very short. 1743.7. What is the difference between the highest and the lowest PFC emissions (in thousand metric tons of CO2 equivalent) in 2008?
Offer a very short reply. 1856.4. 